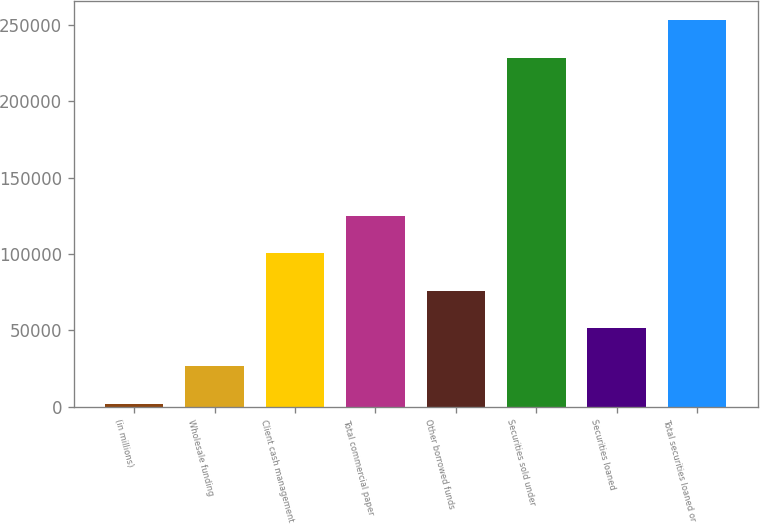Convert chart to OTSL. <chart><loc_0><loc_0><loc_500><loc_500><bar_chart><fcel>(in millions)<fcel>Wholesale funding<fcel>Client cash management<fcel>Total commercial paper<fcel>Other borrowed funds<fcel>Securities sold under<fcel>Securities loaned<fcel>Total securities loaned or<nl><fcel>2011<fcel>26605.1<fcel>100387<fcel>124982<fcel>75793.3<fcel>228514<fcel>51199.2<fcel>253108<nl></chart> 